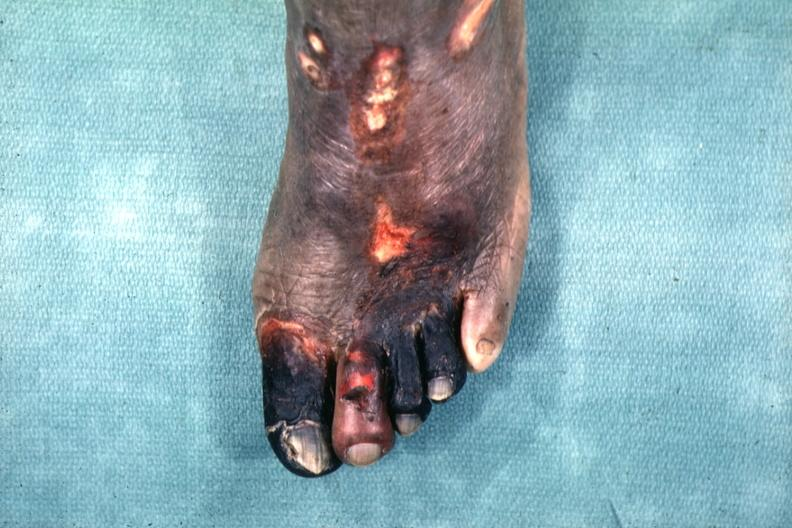how many toes does this image show excellent example of gangrene of the first?
Answer the question using a single word or phrase. Four 